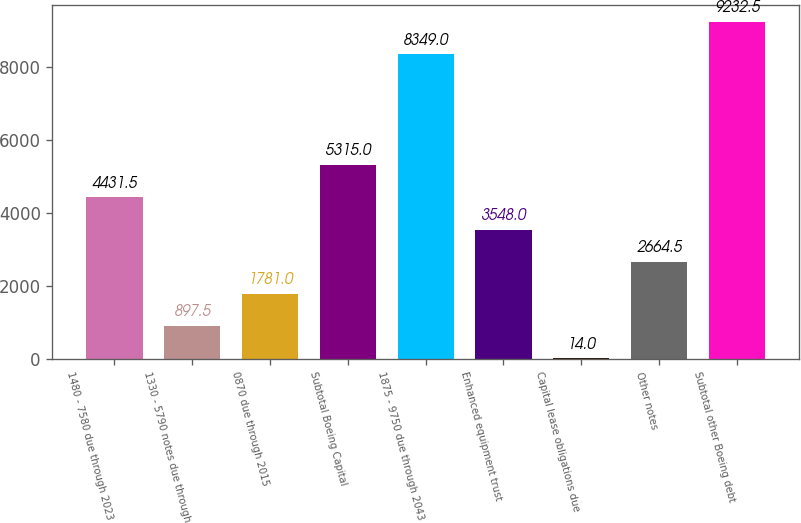Convert chart. <chart><loc_0><loc_0><loc_500><loc_500><bar_chart><fcel>1480 - 7580 due through 2023<fcel>1330 - 5790 notes due through<fcel>0870 due through 2015<fcel>Subtotal Boeing Capital<fcel>1875 - 9750 due through 2043<fcel>Enhanced equipment trust<fcel>Capital lease obligations due<fcel>Other notes<fcel>Subtotal other Boeing debt<nl><fcel>4431.5<fcel>897.5<fcel>1781<fcel>5315<fcel>8349<fcel>3548<fcel>14<fcel>2664.5<fcel>9232.5<nl></chart> 